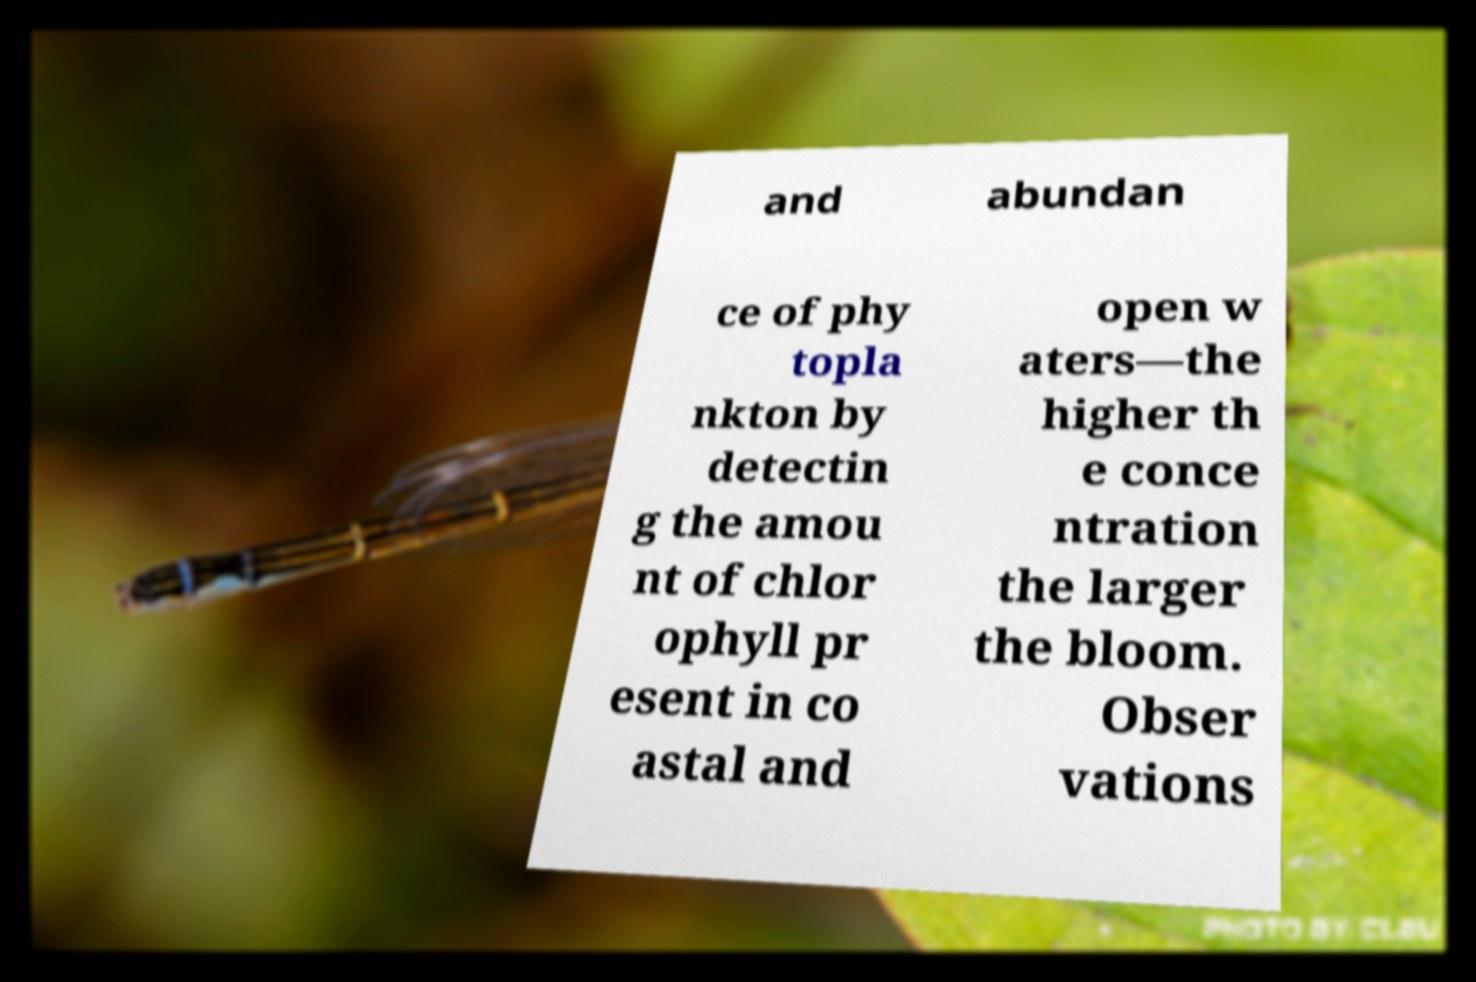For documentation purposes, I need the text within this image transcribed. Could you provide that? and abundan ce of phy topla nkton by detectin g the amou nt of chlor ophyll pr esent in co astal and open w aters—the higher th e conce ntration the larger the bloom. Obser vations 